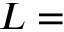<formula> <loc_0><loc_0><loc_500><loc_500>L =</formula> 